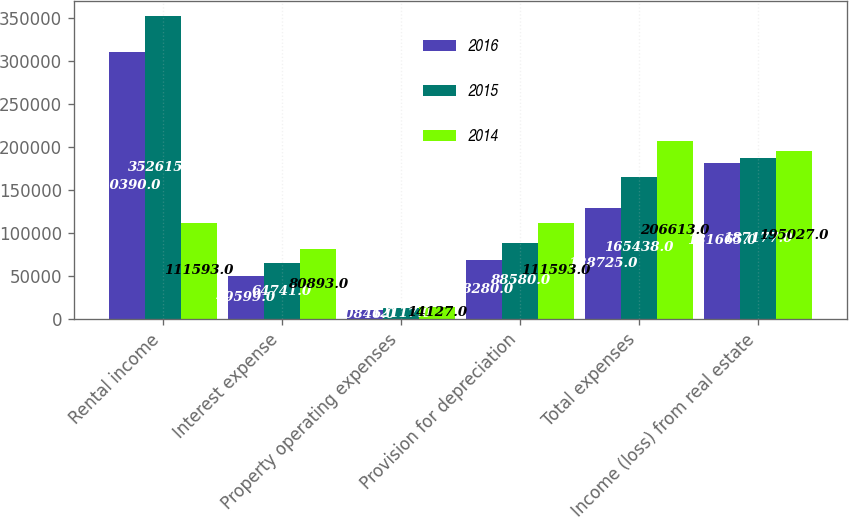Convert chart to OTSL. <chart><loc_0><loc_0><loc_500><loc_500><stacked_bar_chart><ecel><fcel>Rental income<fcel>Interest expense<fcel>Property operating expenses<fcel>Provision for depreciation<fcel>Total expenses<fcel>Income (loss) from real estate<nl><fcel>2016<fcel>310390<fcel>49599<fcel>10846<fcel>68280<fcel>128725<fcel>181665<nl><fcel>2015<fcel>352615<fcel>64741<fcel>12117<fcel>88580<fcel>165438<fcel>187177<nl><fcel>2014<fcel>111593<fcel>80893<fcel>14127<fcel>111593<fcel>206613<fcel>195027<nl></chart> 